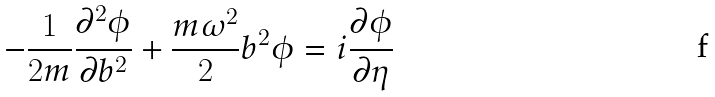Convert formula to latex. <formula><loc_0><loc_0><loc_500><loc_500>- \frac { 1 } { 2 m } \frac { \partial ^ { 2 } \phi } { \partial b ^ { 2 } } + \frac { m \omega ^ { 2 } } { 2 } b ^ { 2 } \phi = i \frac { \partial \phi } { \partial \eta }</formula> 